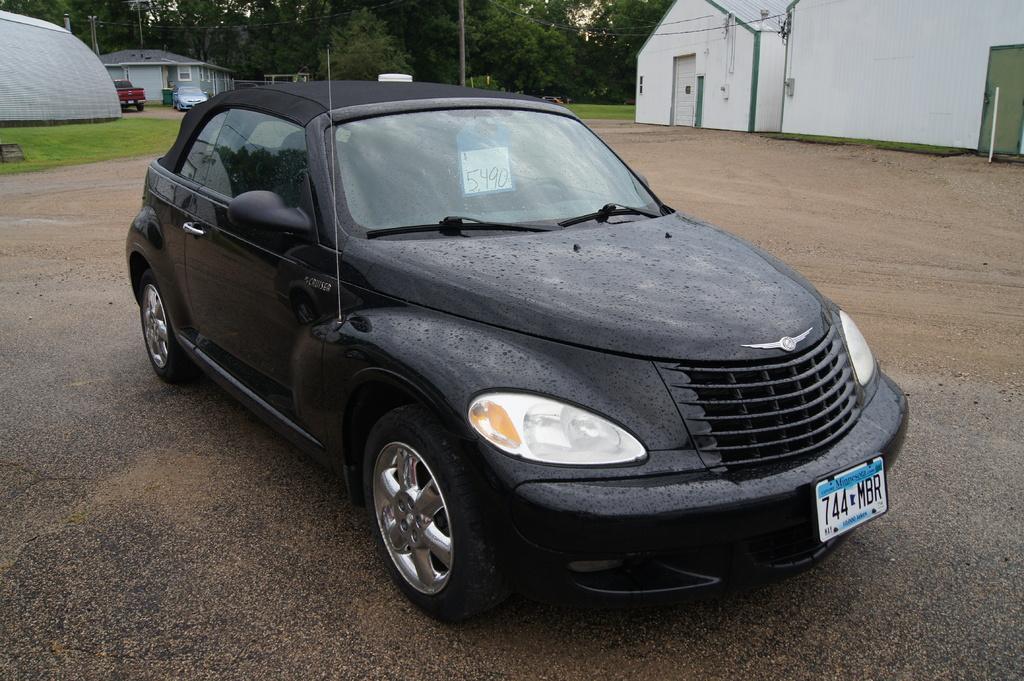How would you summarize this image in a sentence or two? At the bottom of the image there is a road. In the middle of the road there is a black car. Behind the car there are houses with walls and roofs and also there are poles and vehicles on the ground. And in the background there are trees. 